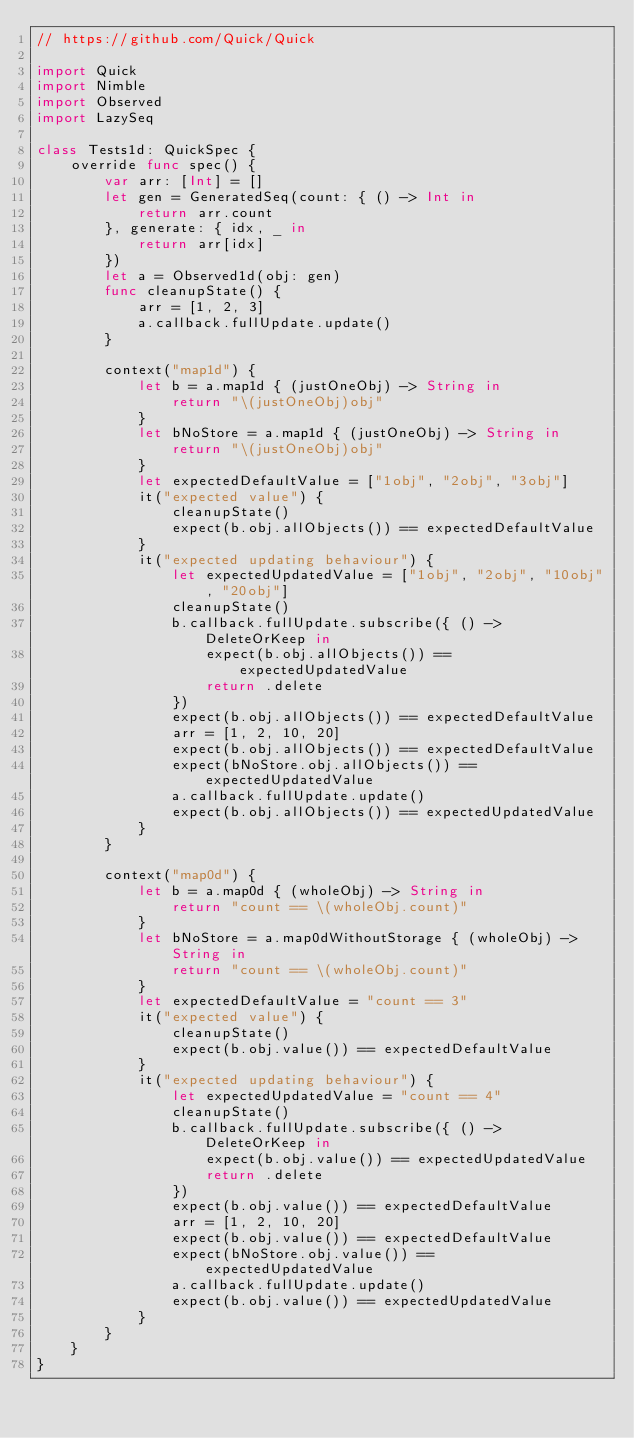<code> <loc_0><loc_0><loc_500><loc_500><_Swift_>// https://github.com/Quick/Quick

import Quick
import Nimble
import Observed
import LazySeq

class Tests1d: QuickSpec {
    override func spec() {
        var arr: [Int] = []
        let gen = GeneratedSeq(count: { () -> Int in
            return arr.count
        }, generate: { idx, _ in
            return arr[idx]
        })
        let a = Observed1d(obj: gen)
        func cleanupState() {
            arr = [1, 2, 3]
            a.callback.fullUpdate.update()
        }
        
        context("map1d") {
            let b = a.map1d { (justOneObj) -> String in
                return "\(justOneObj)obj"
            }
            let bNoStore = a.map1d { (justOneObj) -> String in
                return "\(justOneObj)obj"
            }
            let expectedDefaultValue = ["1obj", "2obj", "3obj"]
            it("expected value") {
                cleanupState()
                expect(b.obj.allObjects()) == expectedDefaultValue
            }
            it("expected updating behaviour") {
                let expectedUpdatedValue = ["1obj", "2obj", "10obj", "20obj"]
                cleanupState()
                b.callback.fullUpdate.subscribe({ () -> DeleteOrKeep in
                    expect(b.obj.allObjects()) == expectedUpdatedValue
                    return .delete
                })
                expect(b.obj.allObjects()) == expectedDefaultValue
                arr = [1, 2, 10, 20]
                expect(b.obj.allObjects()) == expectedDefaultValue
                expect(bNoStore.obj.allObjects()) == expectedUpdatedValue
                a.callback.fullUpdate.update()
                expect(b.obj.allObjects()) == expectedUpdatedValue
            }
        }
        
        context("map0d") {
            let b = a.map0d { (wholeObj) -> String in
                return "count == \(wholeObj.count)"
            }
            let bNoStore = a.map0dWithoutStorage { (wholeObj) -> String in
                return "count == \(wholeObj.count)"
            }
            let expectedDefaultValue = "count == 3"
            it("expected value") {
                cleanupState()
                expect(b.obj.value()) == expectedDefaultValue
            }
            it("expected updating behaviour") {
                let expectedUpdatedValue = "count == 4"
                cleanupState()
                b.callback.fullUpdate.subscribe({ () -> DeleteOrKeep in
                    expect(b.obj.value()) == expectedUpdatedValue
                    return .delete
                })
                expect(b.obj.value()) == expectedDefaultValue
                arr = [1, 2, 10, 20]
                expect(b.obj.value()) == expectedDefaultValue
                expect(bNoStore.obj.value()) == expectedUpdatedValue
                a.callback.fullUpdate.update()
                expect(b.obj.value()) == expectedUpdatedValue
            }
        }
    }
}
</code> 